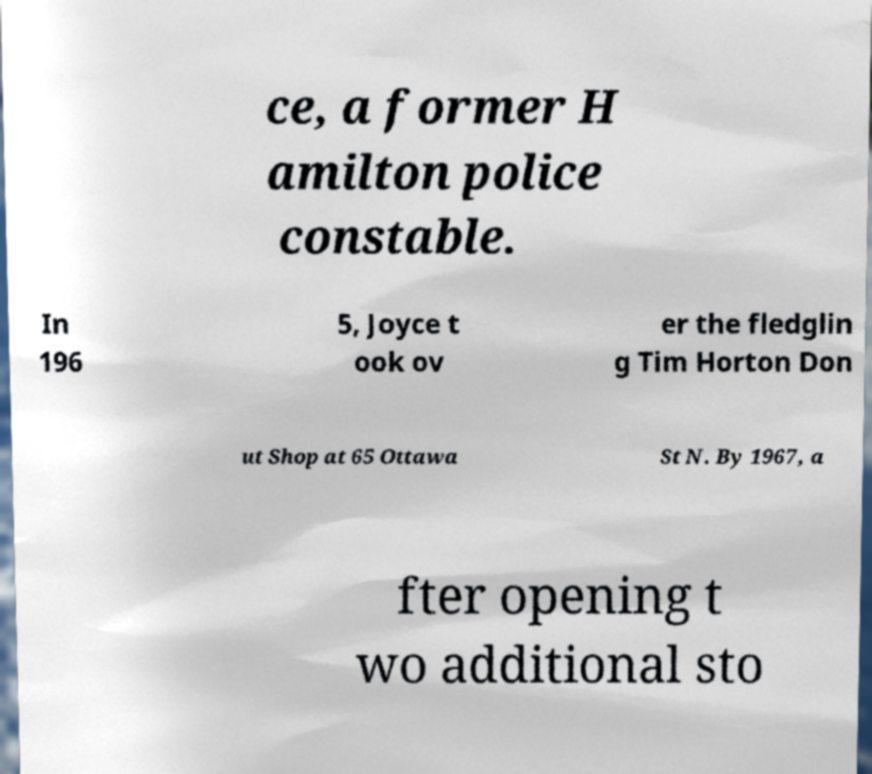Could you assist in decoding the text presented in this image and type it out clearly? ce, a former H amilton police constable. In 196 5, Joyce t ook ov er the fledglin g Tim Horton Don ut Shop at 65 Ottawa St N. By 1967, a fter opening t wo additional sto 